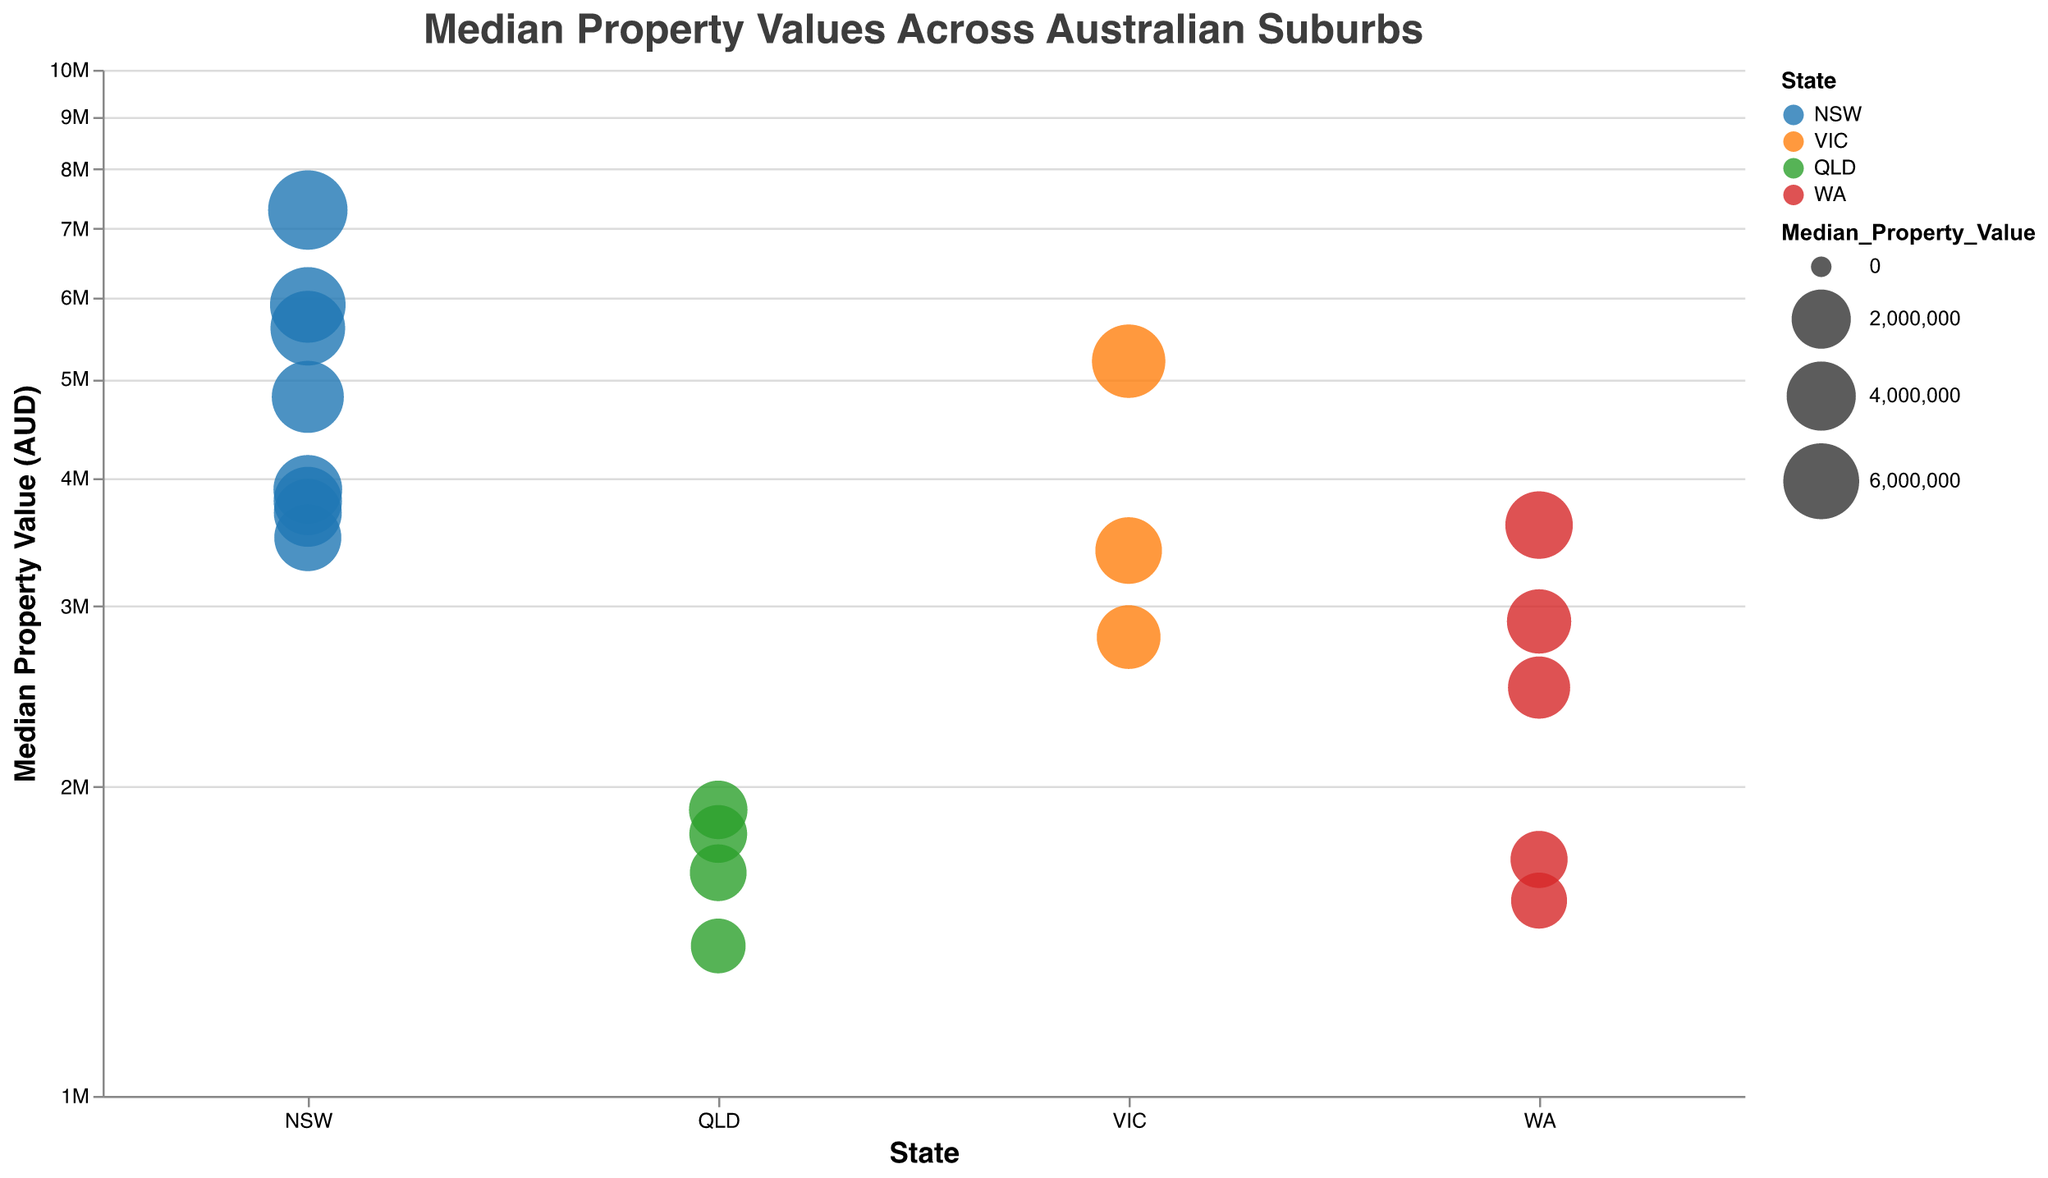What's the median property value for the suburb with the lowest value? From the plot, identify the point on the y-axis that represents the lowest median property value and then locate the suburb name in the tooltip. The lowest value is associated with Noosa Heads, QLD at $1,400,000.
Answer: $1,400,000 Which state has the highest median property value suburb, and what is that value? By observing the highest point on the y-axis and looking at the color representing the state, Point Piper, NSW, has the highest median property value at $7,300,000. Therefore, the state is NSW.
Answer: NSW, $7,300,000 How do the property values in Victoria (VIC) compare to those in Queensland (QLD)? Compare the y-axis values of the median property values for suburbs in VIC (orange-colored points) and QLD (green-colored points). Victorian suburbs (Toorak $5,200,000, Brighton $3,400,000, Portsea $2,800,000) generally have higher median values than Queensland suburbs (Ascot $1,800,000, Hamilton $1,650,000, Noosa Heads $1,400,000, Sunshine Beach $1,900,000).
Answer: VIC generally has higher values What is the average median property value of the top three suburbs in New South Wales (NSW) based on their values? Identify the top three NSW suburbs (Point Piper, Vaucluse, Bellevue Hill). Sum their median values (7,300,000 + 5,900,000 + 5,600,000) and divide by 3 to get the average: (7,300,000 + 5,900,000 + 5,600,000) / 3 = $6,266,667.
Answer: $6,266,667 How many suburbs have a median property value above $4,000,000? Count the number of points above the $4,000,000 mark on the y-axis. Suburbs above this threshold include Toorak, Point Piper, Vaucluse, Bellevue Hill, Mosman. This totals 5 suburbs.
Answer: 5 Which suburb in Western Australia (WA) has the highest median property value, and what is that value? Look for the highest point colored red representing WA. Dalkeith has the highest value in WA at $2,500,000.
Answer: Dalkeith, $2,500,000 What is the total number of suburbs represented in the figure? Count all the points in the figure. There are 20 suburbs listed in the data.
Answer: 20 Which states have suburbs with property values below $2,000,000? Identify the colors and points below the $2,000,000 mark on the y-axis. Queensland (Ascot, Hamilton, Noosa Heads, Sunshine Beach) and Western Australia (Nedlands, Claremont) have suburbs below this value.
Answer: QLD, WA What’s the median property value for the second most expensive suburb in New South Wales (NSW)? Identify the second highest point within NSW colored blue. Vaucluse is the second most expensive suburb with a median value of $5,900,000.
Answer: $5,900,000 